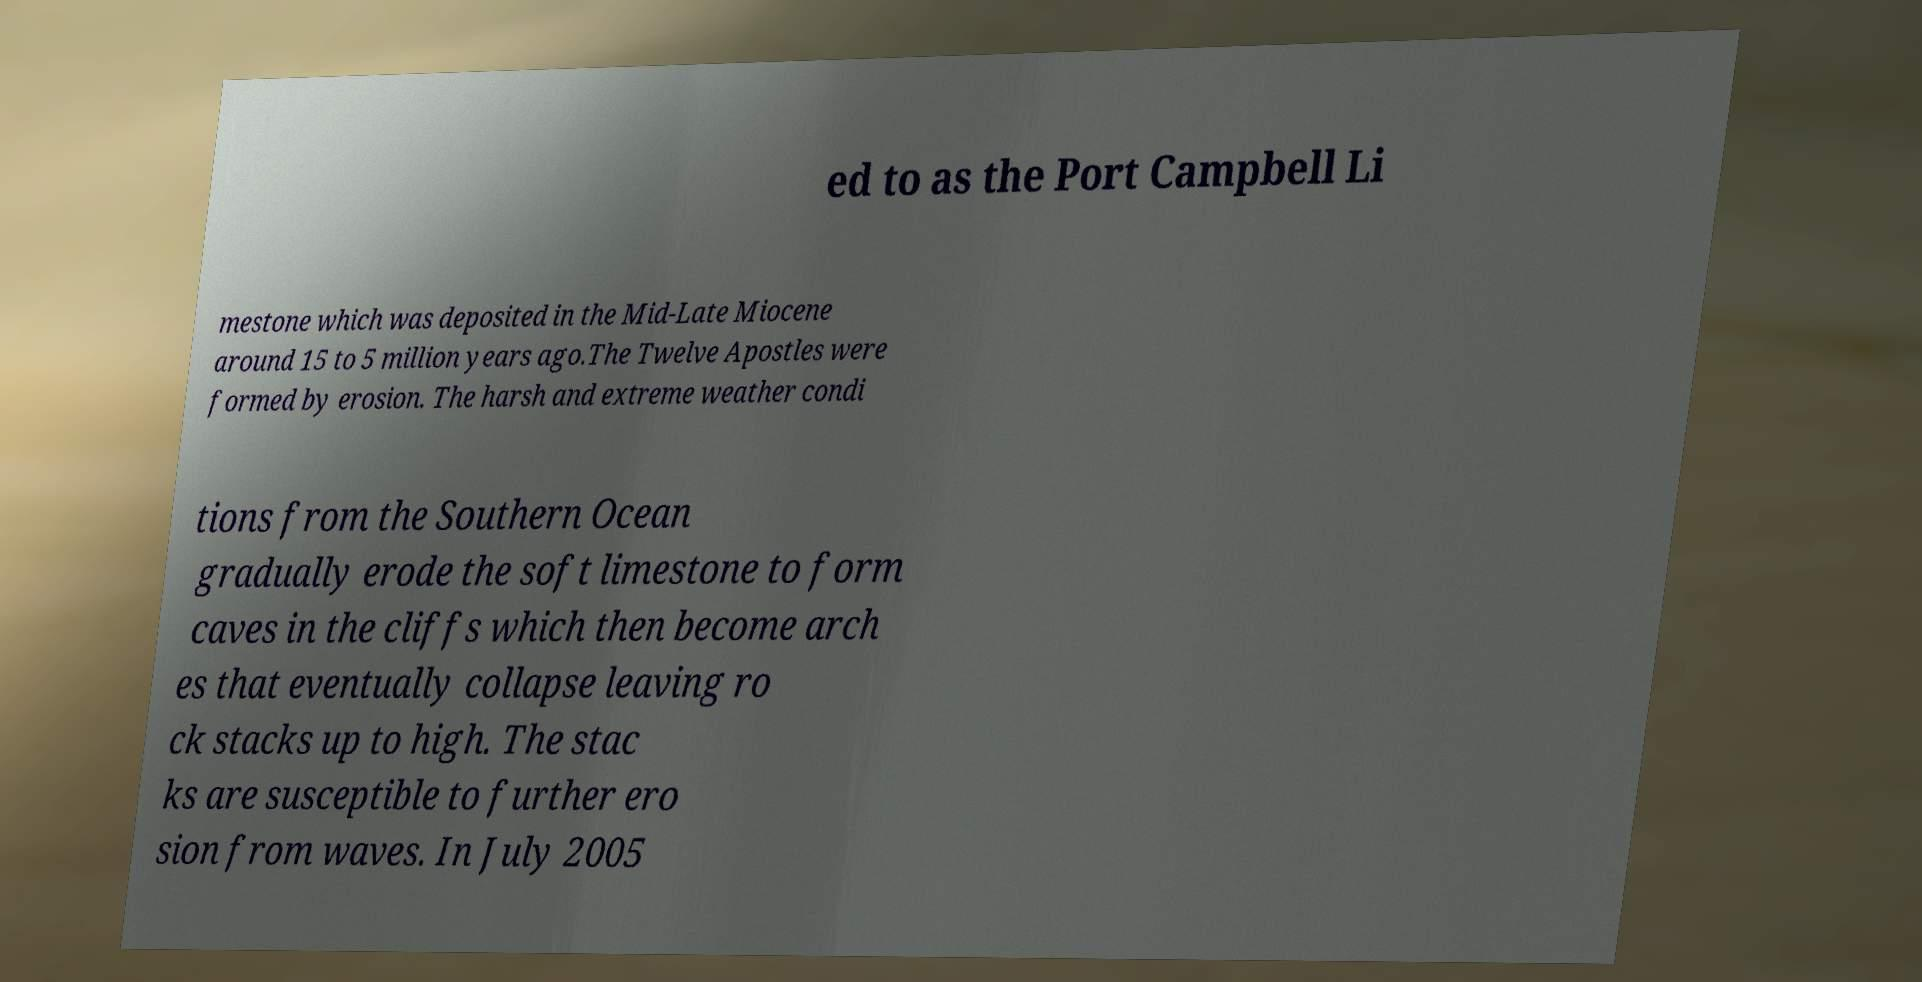Can you read and provide the text displayed in the image?This photo seems to have some interesting text. Can you extract and type it out for me? ed to as the Port Campbell Li mestone which was deposited in the Mid-Late Miocene around 15 to 5 million years ago.The Twelve Apostles were formed by erosion. The harsh and extreme weather condi tions from the Southern Ocean gradually erode the soft limestone to form caves in the cliffs which then become arch es that eventually collapse leaving ro ck stacks up to high. The stac ks are susceptible to further ero sion from waves. In July 2005 